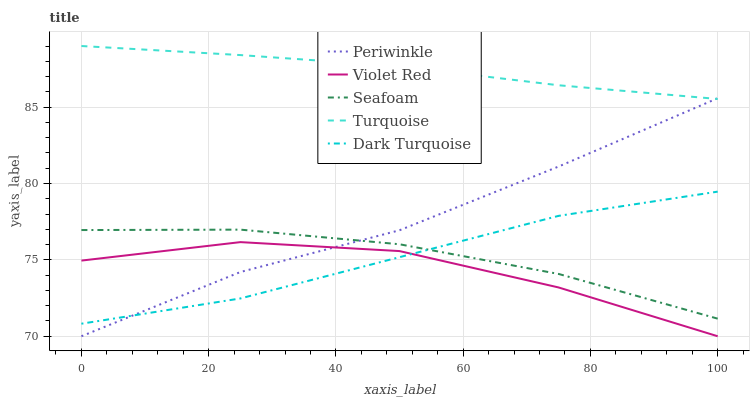Does Violet Red have the minimum area under the curve?
Answer yes or no. Yes. Does Turquoise have the maximum area under the curve?
Answer yes or no. Yes. Does Turquoise have the minimum area under the curve?
Answer yes or no. No. Does Violet Red have the maximum area under the curve?
Answer yes or no. No. Is Turquoise the smoothest?
Answer yes or no. Yes. Is Violet Red the roughest?
Answer yes or no. Yes. Is Violet Red the smoothest?
Answer yes or no. No. Is Turquoise the roughest?
Answer yes or no. No. Does Violet Red have the lowest value?
Answer yes or no. Yes. Does Turquoise have the lowest value?
Answer yes or no. No. Does Turquoise have the highest value?
Answer yes or no. Yes. Does Violet Red have the highest value?
Answer yes or no. No. Is Seafoam less than Turquoise?
Answer yes or no. Yes. Is Turquoise greater than Dark Turquoise?
Answer yes or no. Yes. Does Periwinkle intersect Seafoam?
Answer yes or no. Yes. Is Periwinkle less than Seafoam?
Answer yes or no. No. Is Periwinkle greater than Seafoam?
Answer yes or no. No. Does Seafoam intersect Turquoise?
Answer yes or no. No. 